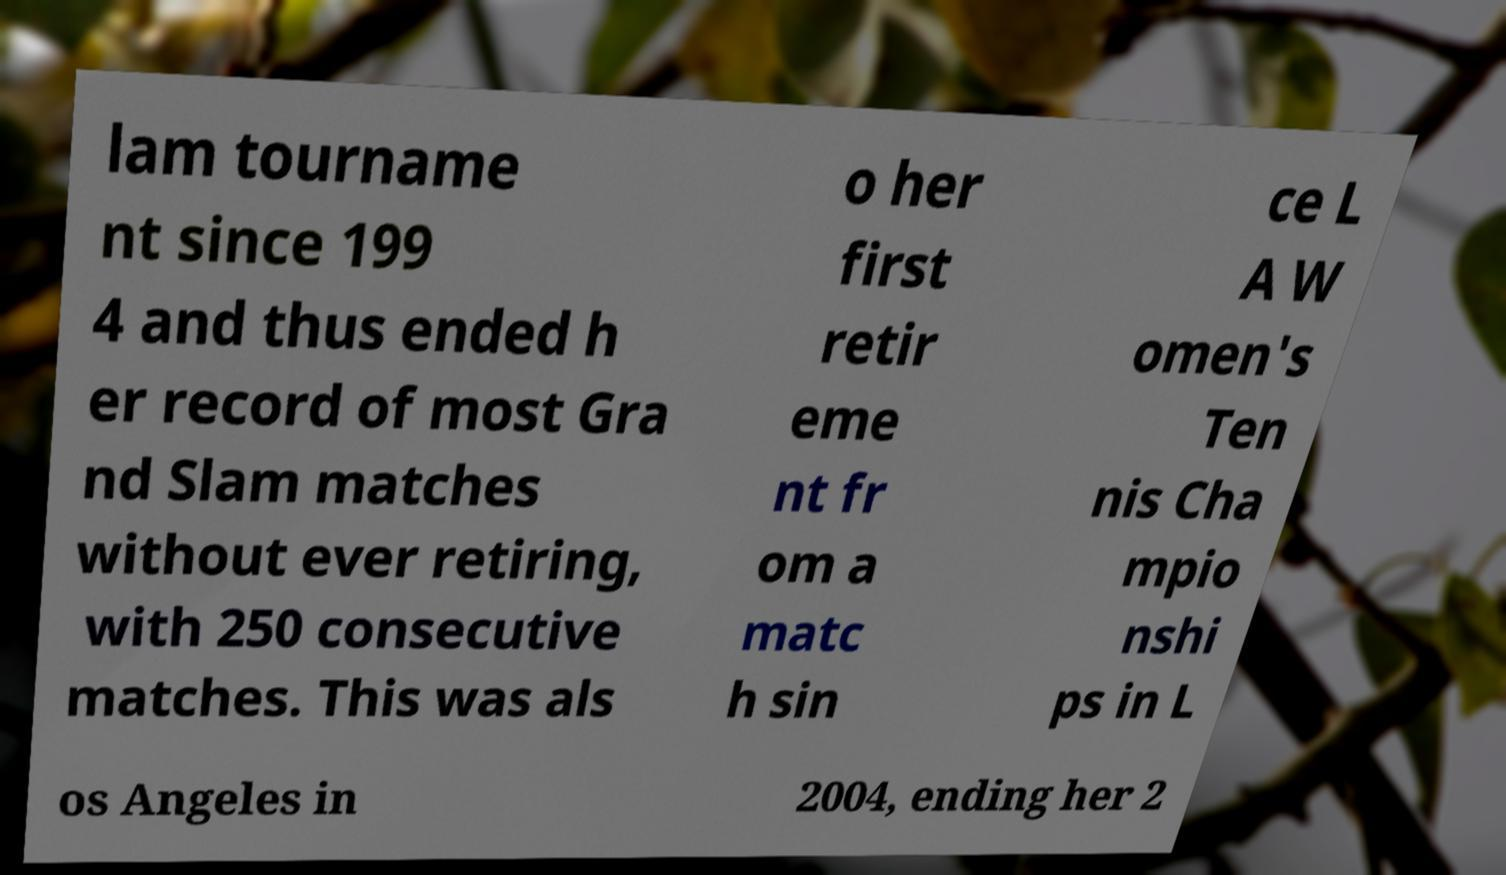Please identify and transcribe the text found in this image. lam tourname nt since 199 4 and thus ended h er record of most Gra nd Slam matches without ever retiring, with 250 consecutive matches. This was als o her first retir eme nt fr om a matc h sin ce L A W omen's Ten nis Cha mpio nshi ps in L os Angeles in 2004, ending her 2 